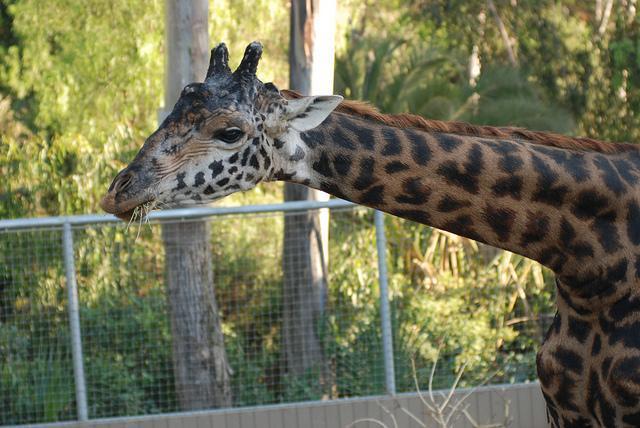How many people are riding elephants?
Give a very brief answer. 0. 